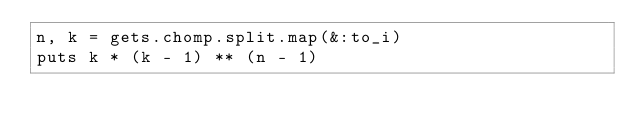Convert code to text. <code><loc_0><loc_0><loc_500><loc_500><_Ruby_>n, k = gets.chomp.split.map(&:to_i)
puts k * (k - 1) ** (n - 1)</code> 